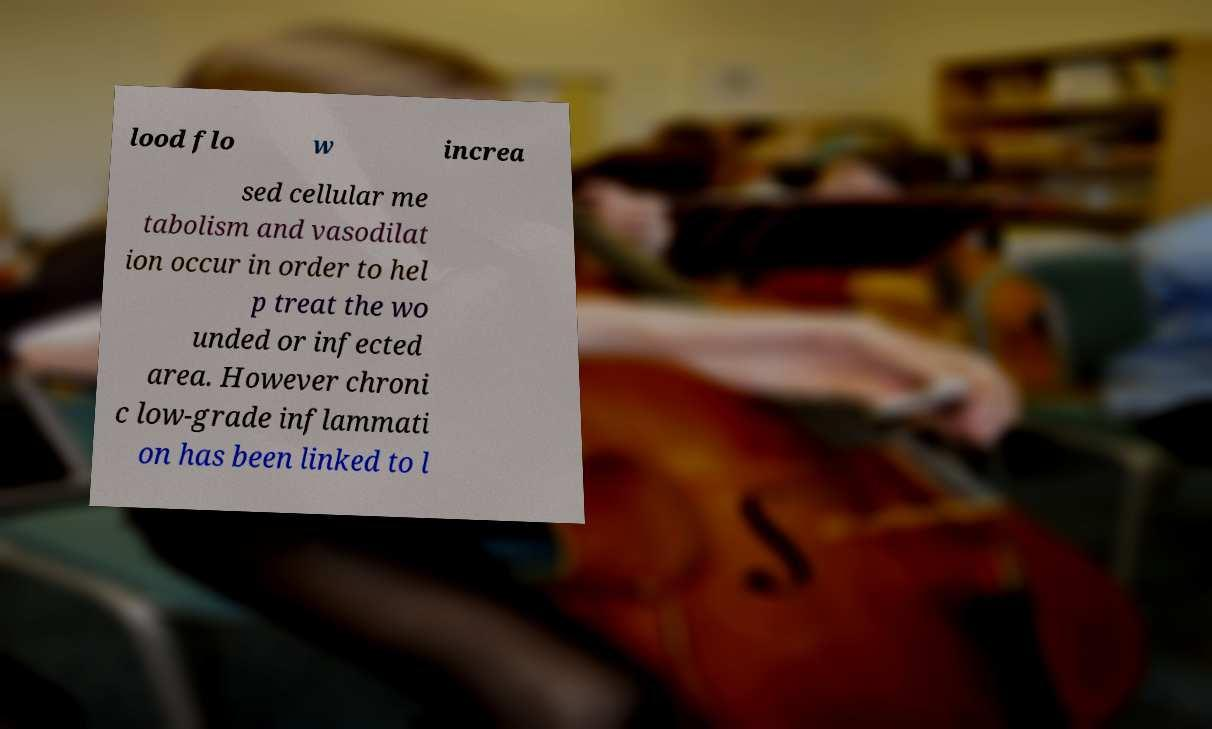Can you accurately transcribe the text from the provided image for me? lood flo w increa sed cellular me tabolism and vasodilat ion occur in order to hel p treat the wo unded or infected area. However chroni c low-grade inflammati on has been linked to l 